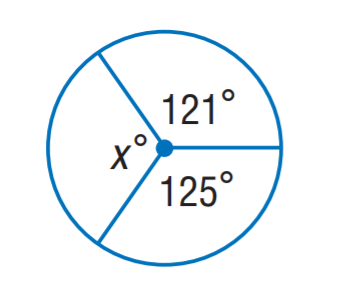Question: Find x.
Choices:
A. 114
B. 118
C. 121
D. 125
Answer with the letter. Answer: A 